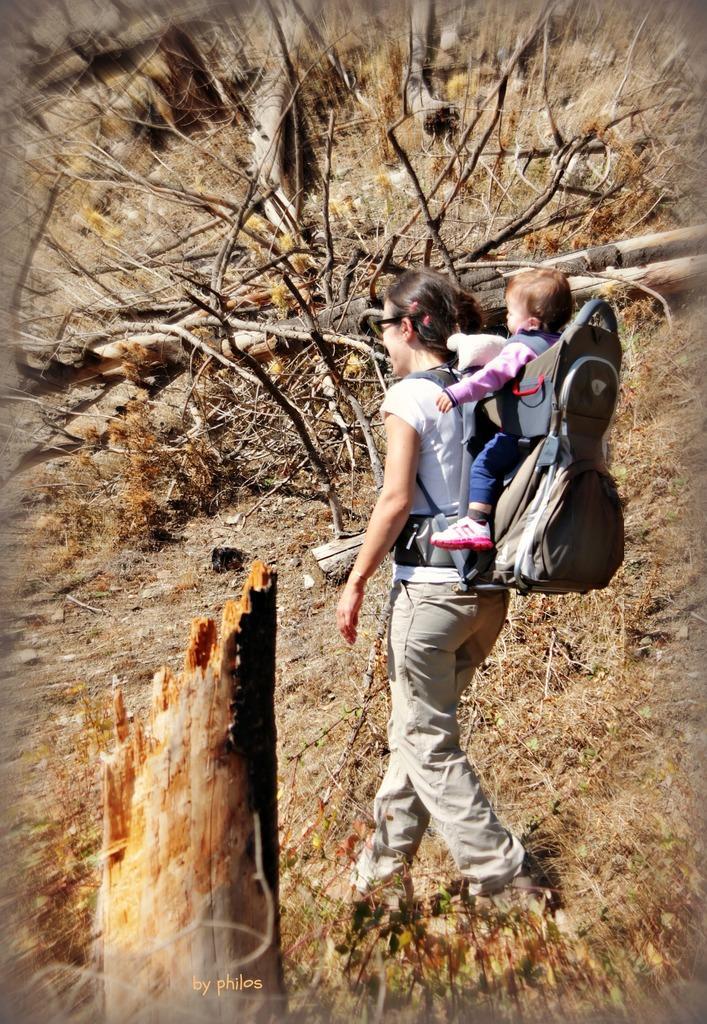In one or two sentences, can you explain what this image depicts? In this image we can see a lady carrying a baby on her back. There are many twigs and few wooden logs on the ground. There are many leaves on the ground. 